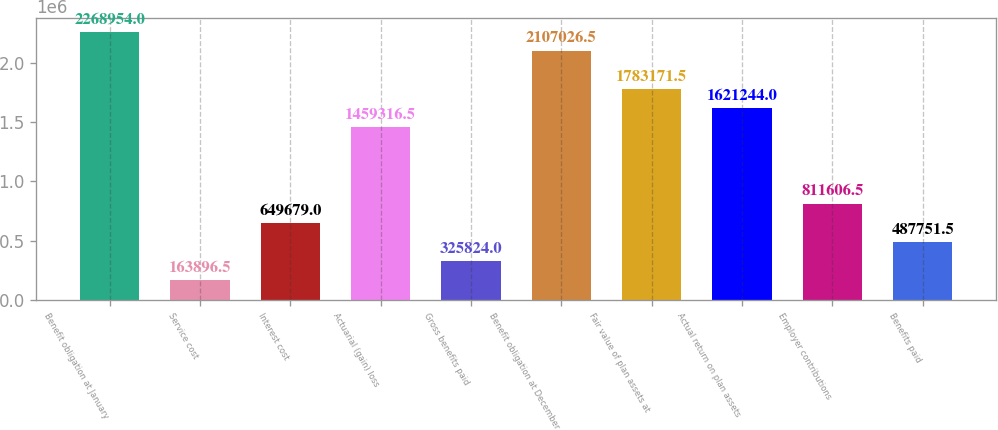<chart> <loc_0><loc_0><loc_500><loc_500><bar_chart><fcel>Benefit obligation at January<fcel>Service cost<fcel>Interest cost<fcel>Actuarial (gain) loss<fcel>Gross benefits paid<fcel>Benefit obligation at December<fcel>Fair value of plan assets at<fcel>Actual return on plan assets<fcel>Employer contributions<fcel>Benefits paid<nl><fcel>2.26895e+06<fcel>163896<fcel>649679<fcel>1.45932e+06<fcel>325824<fcel>2.10703e+06<fcel>1.78317e+06<fcel>1.62124e+06<fcel>811606<fcel>487752<nl></chart> 